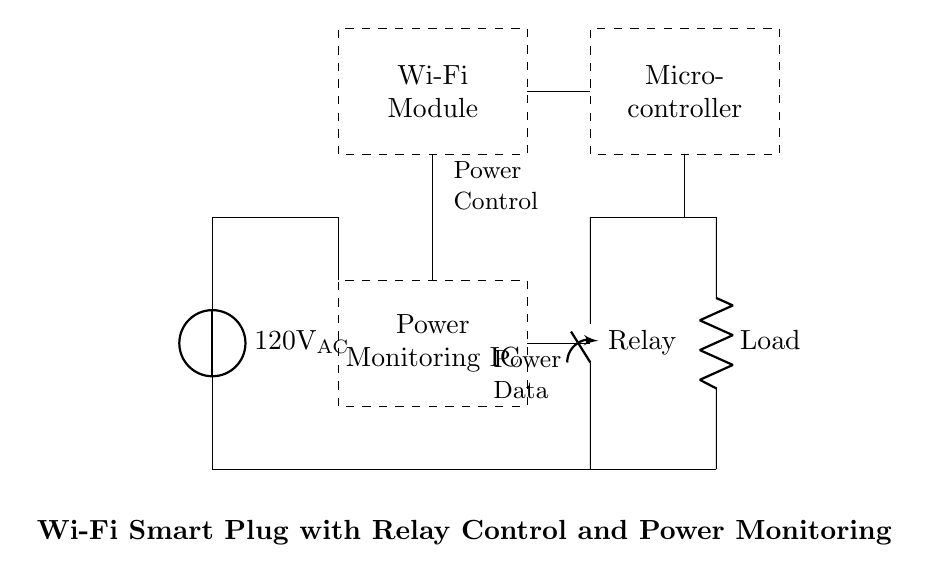What is the voltage of this circuit? The circuit diagram indicates a power source labelled as 120V AC, meaning it operates at a voltage of 120 volts alternating current. This voltage is a standard for household appliances in many regions.
Answer: 120 volts AC What components are involved in this smart plug circuit? The circuit includes a Wi-Fi Module, a Microcontroller, a Power Monitoring IC, a Relay, and a Load. Each component serves a specific function in controlling and monitoring power to the connected load.
Answer: Wi-Fi Module, Microcontroller, Power Monitoring IC, Relay, Load What type of current does the power source provide? The power source in this circuit is designated as 120V AC, indicating that it supplies alternating current, which is common for home electrical systems.
Answer: Alternating current How does the power monitoring IC connect to the microcontroller? The Power Monitoring IC connects to the Microcontroller through a line indicated in the diagram. The connection shows that the Power Monitoring IC sends information about the power usage to the Microcontroller for processing and control logic.
Answer: Direct line connection What is the role of the relay in this circuit? The relay functions as a switch that opens and closes to control power to the Load based on signals received from the Microcontroller, enabling or disabling the connected appliance. This control mechanism allows remote operation through Wi-Fi.
Answer: Power control switch Which component is responsible for Wi-Fi connectivity? The component responsible for Wi-Fi connectivity is the Wi-Fi Module, which allows the smart plug to communicate with other devices and networks for remote control.
Answer: Wi-Fi Module What is the purpose of the load in this circuit? The Load represents the appliance or device that is being powered by the smart plug. It is the final component that receives electric current, enabling it to function according to the smart plug's controls.
Answer: Appliance or device being powered 